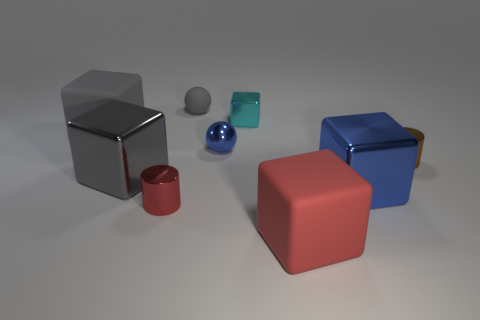Subtract all cyan cubes. How many cubes are left? 4 Subtract all large red matte blocks. How many blocks are left? 4 Subtract all brown cubes. Subtract all cyan balls. How many cubes are left? 5 Add 1 large blue shiny cylinders. How many objects exist? 10 Subtract all spheres. How many objects are left? 7 Subtract all gray cubes. Subtract all large metal things. How many objects are left? 5 Add 4 tiny brown cylinders. How many tiny brown cylinders are left? 5 Add 4 yellow shiny things. How many yellow shiny things exist? 4 Subtract 1 cyan blocks. How many objects are left? 8 